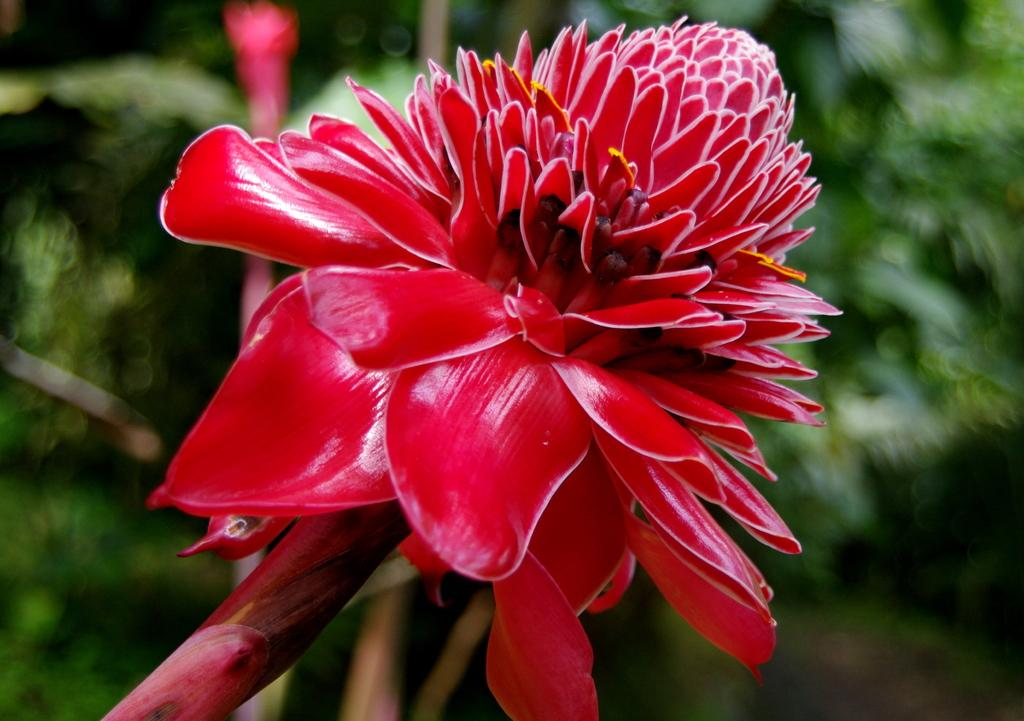What type of flower is in the image? There is a red color flower in the image. What is the flower a part of? The flower belongs to a plant. Can you describe the background of the image? The background of the image is blurred. What is the price of the birthday cake in the image? There is no birthday cake present in the image, so it is not possible to determine its price. 